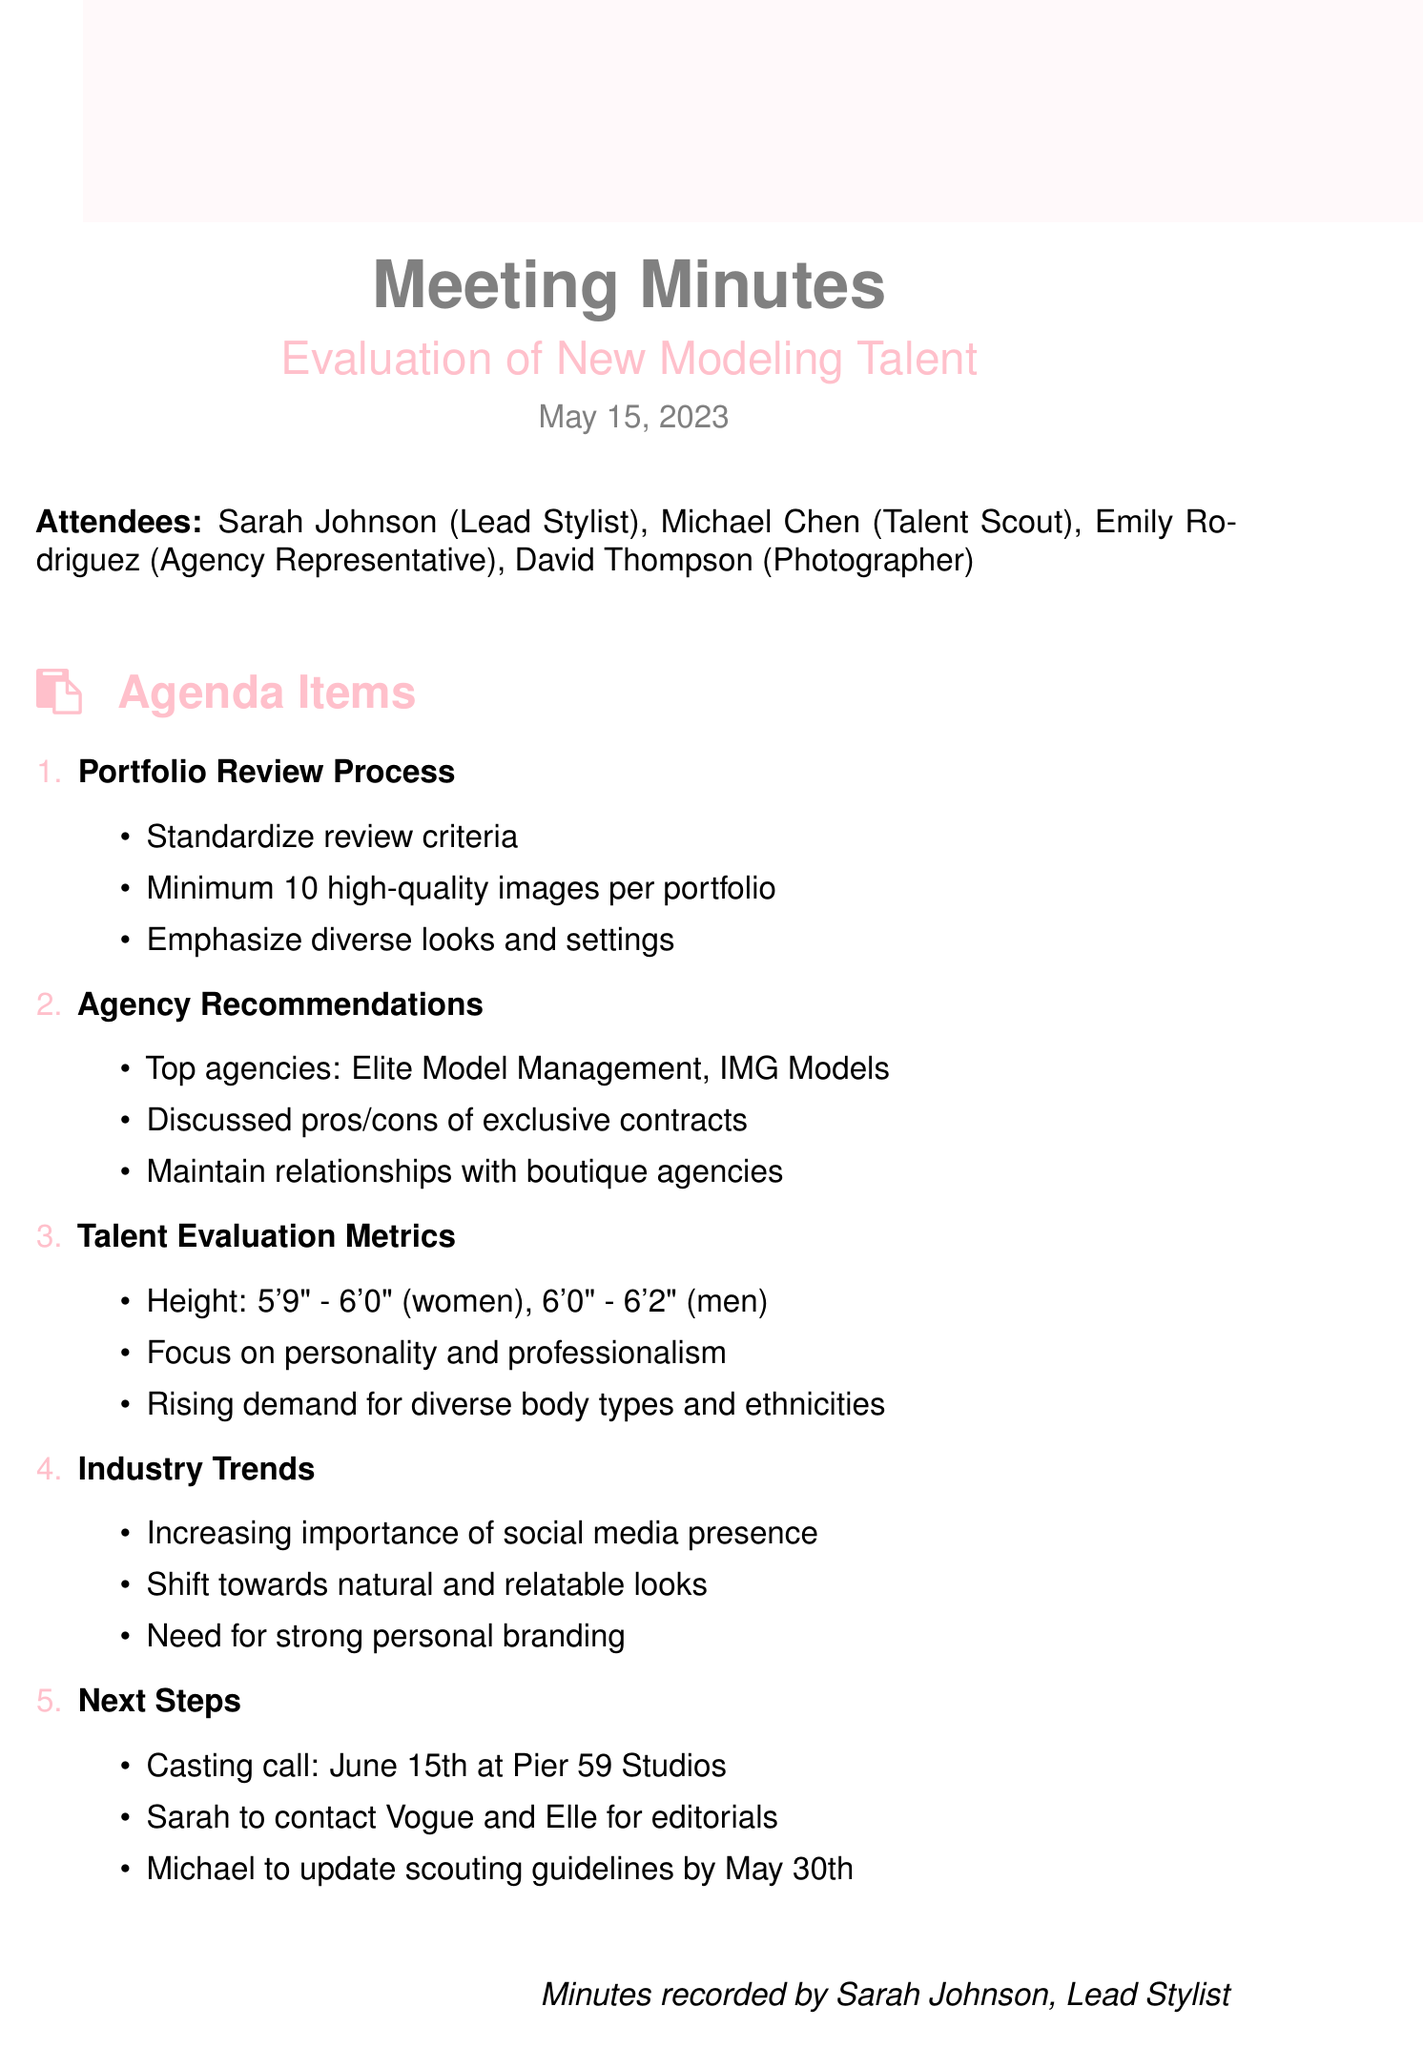what is the meeting date? The meeting date is provided in the document, which is May 15, 2023.
Answer: May 15, 2023 who is the lead stylist? The document lists Sarah Johnson as the lead stylist among the attendees.
Answer: Sarah Johnson what is the minimum number of images required per portfolio? The document specifies that a minimum of 10 high-quality images is required per portfolio review.
Answer: 10 high-quality images what are the height requirements for women? The document states the height requirement for women is 5'9" - 6'0".
Answer: 5'9" - 6'0" which agencies were identified as top agencies for new talent? The document mentions Elite Model Management and IMG Models as top agencies.
Answer: Elite Model Management and IMG Models what is the purpose of the casting call scheduled for June 15th? The casting call on June 15th is intended for evaluating new modeling talent.
Answer: Evaluating new modeling talent why is personality emphasized in talent evaluation metrics? The document emphasizes personality due to its importance during casting calls.
Answer: Importance during casting calls what is a trend noted in the industry regarding model looks? The document highlights a shift towards more natural and relatable looks in the industry trends.
Answer: More natural and relatable looks 